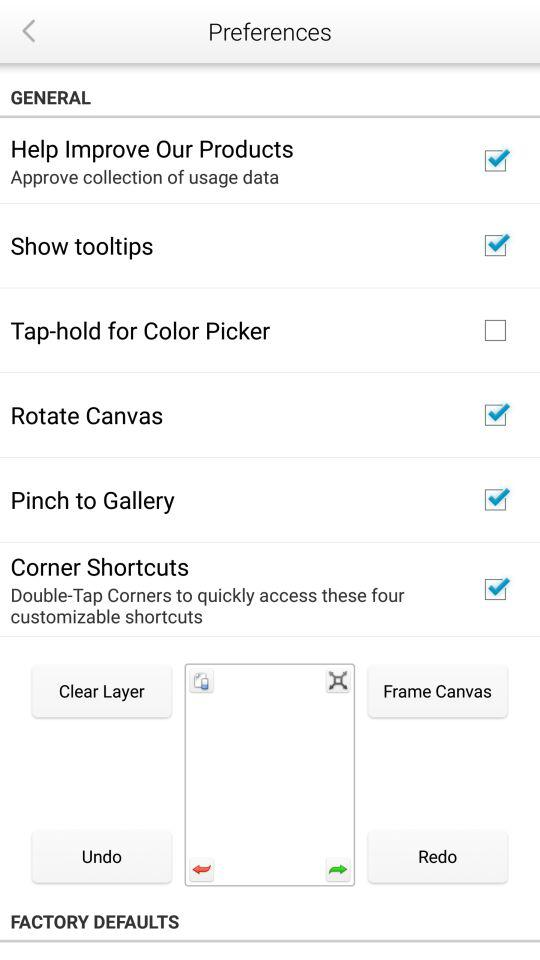What is the status of "Tap-hold for Color Picker"? The status is "off". 